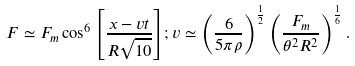<formula> <loc_0><loc_0><loc_500><loc_500>F \simeq F _ { m } \cos ^ { 6 } { \left [ \frac { x - v t } { R \sqrt { 1 0 } } \right ] } ; v \simeq \left ( \frac { 6 } { 5 \pi \rho } \right ) ^ { \frac { 1 } { 2 } } \left ( \frac { F _ { m } } { \theta ^ { 2 } R ^ { 2 } } \right ) ^ { \frac { 1 } { 6 } } .</formula> 